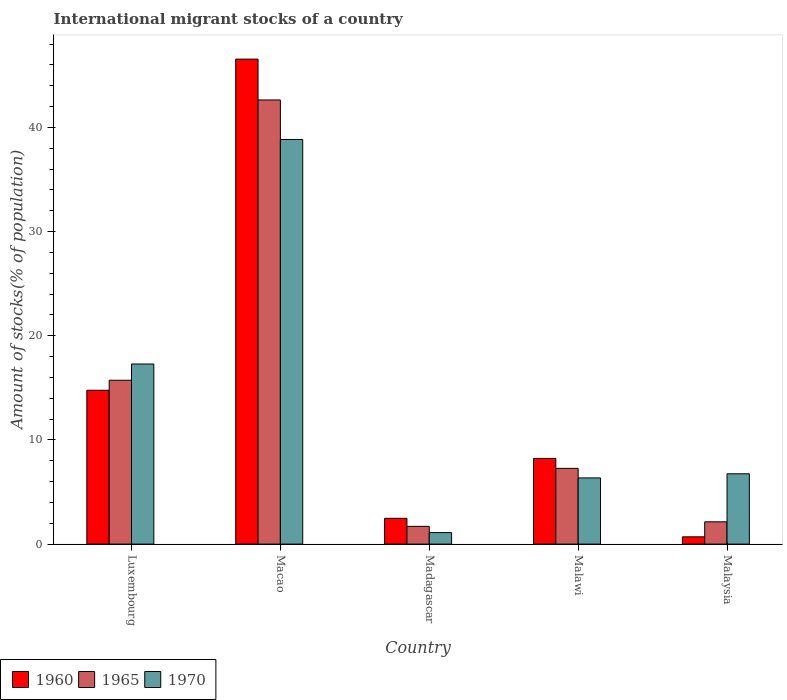How many different coloured bars are there?
Give a very brief answer. 3. How many groups of bars are there?
Give a very brief answer. 5. Are the number of bars per tick equal to the number of legend labels?
Offer a terse response. Yes. Are the number of bars on each tick of the X-axis equal?
Offer a terse response. Yes. How many bars are there on the 4th tick from the left?
Provide a short and direct response. 3. How many bars are there on the 1st tick from the right?
Ensure brevity in your answer.  3. What is the label of the 2nd group of bars from the left?
Your answer should be very brief. Macao. In how many cases, is the number of bars for a given country not equal to the number of legend labels?
Provide a succinct answer. 0. What is the amount of stocks in in 1960 in Malaysia?
Offer a terse response. 0.7. Across all countries, what is the maximum amount of stocks in in 1965?
Your response must be concise. 42.64. Across all countries, what is the minimum amount of stocks in in 1965?
Your answer should be very brief. 1.7. In which country was the amount of stocks in in 1960 maximum?
Your answer should be compact. Macao. In which country was the amount of stocks in in 1960 minimum?
Your response must be concise. Malaysia. What is the total amount of stocks in in 1960 in the graph?
Ensure brevity in your answer.  72.73. What is the difference between the amount of stocks in in 1965 in Luxembourg and that in Madagascar?
Provide a succinct answer. 14.03. What is the difference between the amount of stocks in in 1965 in Malaysia and the amount of stocks in in 1960 in Malawi?
Keep it short and to the point. -6.09. What is the average amount of stocks in in 1960 per country?
Make the answer very short. 14.55. What is the difference between the amount of stocks in of/in 1970 and amount of stocks in of/in 1965 in Macao?
Offer a very short reply. -3.79. In how many countries, is the amount of stocks in in 1965 greater than 4 %?
Give a very brief answer. 3. What is the ratio of the amount of stocks in in 1970 in Luxembourg to that in Madagascar?
Offer a terse response. 15.66. What is the difference between the highest and the second highest amount of stocks in in 1965?
Keep it short and to the point. 35.37. What is the difference between the highest and the lowest amount of stocks in in 1960?
Your answer should be very brief. 45.86. What does the 3rd bar from the left in Madagascar represents?
Provide a succinct answer. 1970. What does the 3rd bar from the right in Macao represents?
Give a very brief answer. 1960. Is it the case that in every country, the sum of the amount of stocks in in 1960 and amount of stocks in in 1965 is greater than the amount of stocks in in 1970?
Provide a short and direct response. No. How many bars are there?
Ensure brevity in your answer.  15. Are all the bars in the graph horizontal?
Your answer should be compact. No. How many countries are there in the graph?
Your answer should be very brief. 5. What is the difference between two consecutive major ticks on the Y-axis?
Ensure brevity in your answer.  10. Are the values on the major ticks of Y-axis written in scientific E-notation?
Offer a very short reply. No. How many legend labels are there?
Your answer should be compact. 3. How are the legend labels stacked?
Provide a succinct answer. Horizontal. What is the title of the graph?
Your answer should be very brief. International migrant stocks of a country. What is the label or title of the Y-axis?
Your answer should be very brief. Amount of stocks(% of population). What is the Amount of stocks(% of population) of 1960 in Luxembourg?
Provide a short and direct response. 14.77. What is the Amount of stocks(% of population) of 1965 in Luxembourg?
Make the answer very short. 15.73. What is the Amount of stocks(% of population) of 1970 in Luxembourg?
Provide a succinct answer. 17.29. What is the Amount of stocks(% of population) in 1960 in Macao?
Your response must be concise. 46.56. What is the Amount of stocks(% of population) of 1965 in Macao?
Offer a very short reply. 42.64. What is the Amount of stocks(% of population) of 1970 in Macao?
Make the answer very short. 38.85. What is the Amount of stocks(% of population) in 1960 in Madagascar?
Ensure brevity in your answer.  2.48. What is the Amount of stocks(% of population) in 1965 in Madagascar?
Offer a terse response. 1.7. What is the Amount of stocks(% of population) in 1970 in Madagascar?
Provide a succinct answer. 1.1. What is the Amount of stocks(% of population) of 1960 in Malawi?
Provide a short and direct response. 8.23. What is the Amount of stocks(% of population) of 1965 in Malawi?
Ensure brevity in your answer.  7.27. What is the Amount of stocks(% of population) of 1970 in Malawi?
Provide a short and direct response. 6.35. What is the Amount of stocks(% of population) of 1960 in Malaysia?
Keep it short and to the point. 0.7. What is the Amount of stocks(% of population) in 1965 in Malaysia?
Make the answer very short. 2.14. What is the Amount of stocks(% of population) in 1970 in Malaysia?
Make the answer very short. 6.75. Across all countries, what is the maximum Amount of stocks(% of population) of 1960?
Give a very brief answer. 46.56. Across all countries, what is the maximum Amount of stocks(% of population) in 1965?
Your answer should be very brief. 42.64. Across all countries, what is the maximum Amount of stocks(% of population) in 1970?
Your response must be concise. 38.85. Across all countries, what is the minimum Amount of stocks(% of population) of 1960?
Your answer should be compact. 0.7. Across all countries, what is the minimum Amount of stocks(% of population) in 1965?
Your answer should be compact. 1.7. Across all countries, what is the minimum Amount of stocks(% of population) in 1970?
Offer a terse response. 1.1. What is the total Amount of stocks(% of population) in 1960 in the graph?
Ensure brevity in your answer.  72.73. What is the total Amount of stocks(% of population) in 1965 in the graph?
Provide a succinct answer. 69.49. What is the total Amount of stocks(% of population) in 1970 in the graph?
Your answer should be compact. 70.35. What is the difference between the Amount of stocks(% of population) in 1960 in Luxembourg and that in Macao?
Provide a succinct answer. -31.79. What is the difference between the Amount of stocks(% of population) of 1965 in Luxembourg and that in Macao?
Your response must be concise. -26.91. What is the difference between the Amount of stocks(% of population) of 1970 in Luxembourg and that in Macao?
Your response must be concise. -21.56. What is the difference between the Amount of stocks(% of population) of 1960 in Luxembourg and that in Madagascar?
Give a very brief answer. 12.29. What is the difference between the Amount of stocks(% of population) of 1965 in Luxembourg and that in Madagascar?
Provide a short and direct response. 14.03. What is the difference between the Amount of stocks(% of population) in 1970 in Luxembourg and that in Madagascar?
Your answer should be compact. 16.19. What is the difference between the Amount of stocks(% of population) of 1960 in Luxembourg and that in Malawi?
Offer a very short reply. 6.54. What is the difference between the Amount of stocks(% of population) in 1965 in Luxembourg and that in Malawi?
Your response must be concise. 8.46. What is the difference between the Amount of stocks(% of population) in 1970 in Luxembourg and that in Malawi?
Keep it short and to the point. 10.94. What is the difference between the Amount of stocks(% of population) in 1960 in Luxembourg and that in Malaysia?
Offer a terse response. 14.07. What is the difference between the Amount of stocks(% of population) in 1965 in Luxembourg and that in Malaysia?
Your answer should be compact. 13.59. What is the difference between the Amount of stocks(% of population) in 1970 in Luxembourg and that in Malaysia?
Offer a very short reply. 10.54. What is the difference between the Amount of stocks(% of population) in 1960 in Macao and that in Madagascar?
Give a very brief answer. 44.08. What is the difference between the Amount of stocks(% of population) of 1965 in Macao and that in Madagascar?
Make the answer very short. 40.94. What is the difference between the Amount of stocks(% of population) of 1970 in Macao and that in Madagascar?
Ensure brevity in your answer.  37.74. What is the difference between the Amount of stocks(% of population) of 1960 in Macao and that in Malawi?
Ensure brevity in your answer.  38.33. What is the difference between the Amount of stocks(% of population) of 1965 in Macao and that in Malawi?
Provide a short and direct response. 35.37. What is the difference between the Amount of stocks(% of population) of 1970 in Macao and that in Malawi?
Your answer should be very brief. 32.49. What is the difference between the Amount of stocks(% of population) in 1960 in Macao and that in Malaysia?
Provide a short and direct response. 45.86. What is the difference between the Amount of stocks(% of population) in 1965 in Macao and that in Malaysia?
Your answer should be compact. 40.5. What is the difference between the Amount of stocks(% of population) in 1970 in Macao and that in Malaysia?
Offer a very short reply. 32.1. What is the difference between the Amount of stocks(% of population) in 1960 in Madagascar and that in Malawi?
Keep it short and to the point. -5.75. What is the difference between the Amount of stocks(% of population) in 1965 in Madagascar and that in Malawi?
Make the answer very short. -5.57. What is the difference between the Amount of stocks(% of population) of 1970 in Madagascar and that in Malawi?
Ensure brevity in your answer.  -5.25. What is the difference between the Amount of stocks(% of population) in 1960 in Madagascar and that in Malaysia?
Give a very brief answer. 1.78. What is the difference between the Amount of stocks(% of population) of 1965 in Madagascar and that in Malaysia?
Provide a succinct answer. -0.43. What is the difference between the Amount of stocks(% of population) in 1970 in Madagascar and that in Malaysia?
Offer a terse response. -5.65. What is the difference between the Amount of stocks(% of population) of 1960 in Malawi and that in Malaysia?
Keep it short and to the point. 7.53. What is the difference between the Amount of stocks(% of population) of 1965 in Malawi and that in Malaysia?
Provide a succinct answer. 5.13. What is the difference between the Amount of stocks(% of population) of 1970 in Malawi and that in Malaysia?
Provide a short and direct response. -0.4. What is the difference between the Amount of stocks(% of population) in 1960 in Luxembourg and the Amount of stocks(% of population) in 1965 in Macao?
Give a very brief answer. -27.87. What is the difference between the Amount of stocks(% of population) in 1960 in Luxembourg and the Amount of stocks(% of population) in 1970 in Macao?
Provide a short and direct response. -24.08. What is the difference between the Amount of stocks(% of population) in 1965 in Luxembourg and the Amount of stocks(% of population) in 1970 in Macao?
Ensure brevity in your answer.  -23.12. What is the difference between the Amount of stocks(% of population) of 1960 in Luxembourg and the Amount of stocks(% of population) of 1965 in Madagascar?
Give a very brief answer. 13.06. What is the difference between the Amount of stocks(% of population) of 1960 in Luxembourg and the Amount of stocks(% of population) of 1970 in Madagascar?
Give a very brief answer. 13.67. What is the difference between the Amount of stocks(% of population) in 1965 in Luxembourg and the Amount of stocks(% of population) in 1970 in Madagascar?
Provide a short and direct response. 14.63. What is the difference between the Amount of stocks(% of population) of 1960 in Luxembourg and the Amount of stocks(% of population) of 1965 in Malawi?
Ensure brevity in your answer.  7.5. What is the difference between the Amount of stocks(% of population) in 1960 in Luxembourg and the Amount of stocks(% of population) in 1970 in Malawi?
Provide a succinct answer. 8.42. What is the difference between the Amount of stocks(% of population) of 1965 in Luxembourg and the Amount of stocks(% of population) of 1970 in Malawi?
Provide a succinct answer. 9.38. What is the difference between the Amount of stocks(% of population) in 1960 in Luxembourg and the Amount of stocks(% of population) in 1965 in Malaysia?
Your answer should be very brief. 12.63. What is the difference between the Amount of stocks(% of population) in 1960 in Luxembourg and the Amount of stocks(% of population) in 1970 in Malaysia?
Provide a succinct answer. 8.02. What is the difference between the Amount of stocks(% of population) of 1965 in Luxembourg and the Amount of stocks(% of population) of 1970 in Malaysia?
Ensure brevity in your answer.  8.98. What is the difference between the Amount of stocks(% of population) of 1960 in Macao and the Amount of stocks(% of population) of 1965 in Madagascar?
Your answer should be compact. 44.86. What is the difference between the Amount of stocks(% of population) in 1960 in Macao and the Amount of stocks(% of population) in 1970 in Madagascar?
Keep it short and to the point. 45.46. What is the difference between the Amount of stocks(% of population) in 1965 in Macao and the Amount of stocks(% of population) in 1970 in Madagascar?
Your answer should be very brief. 41.54. What is the difference between the Amount of stocks(% of population) in 1960 in Macao and the Amount of stocks(% of population) in 1965 in Malawi?
Your response must be concise. 39.29. What is the difference between the Amount of stocks(% of population) of 1960 in Macao and the Amount of stocks(% of population) of 1970 in Malawi?
Offer a very short reply. 40.21. What is the difference between the Amount of stocks(% of population) in 1965 in Macao and the Amount of stocks(% of population) in 1970 in Malawi?
Give a very brief answer. 36.29. What is the difference between the Amount of stocks(% of population) in 1960 in Macao and the Amount of stocks(% of population) in 1965 in Malaysia?
Your answer should be compact. 44.42. What is the difference between the Amount of stocks(% of population) in 1960 in Macao and the Amount of stocks(% of population) in 1970 in Malaysia?
Keep it short and to the point. 39.81. What is the difference between the Amount of stocks(% of population) of 1965 in Macao and the Amount of stocks(% of population) of 1970 in Malaysia?
Make the answer very short. 35.89. What is the difference between the Amount of stocks(% of population) of 1960 in Madagascar and the Amount of stocks(% of population) of 1965 in Malawi?
Your answer should be compact. -4.79. What is the difference between the Amount of stocks(% of population) in 1960 in Madagascar and the Amount of stocks(% of population) in 1970 in Malawi?
Give a very brief answer. -3.88. What is the difference between the Amount of stocks(% of population) in 1965 in Madagascar and the Amount of stocks(% of population) in 1970 in Malawi?
Make the answer very short. -4.65. What is the difference between the Amount of stocks(% of population) in 1960 in Madagascar and the Amount of stocks(% of population) in 1965 in Malaysia?
Give a very brief answer. 0.34. What is the difference between the Amount of stocks(% of population) in 1960 in Madagascar and the Amount of stocks(% of population) in 1970 in Malaysia?
Give a very brief answer. -4.27. What is the difference between the Amount of stocks(% of population) in 1965 in Madagascar and the Amount of stocks(% of population) in 1970 in Malaysia?
Provide a succinct answer. -5.04. What is the difference between the Amount of stocks(% of population) of 1960 in Malawi and the Amount of stocks(% of population) of 1965 in Malaysia?
Your answer should be very brief. 6.09. What is the difference between the Amount of stocks(% of population) in 1960 in Malawi and the Amount of stocks(% of population) in 1970 in Malaysia?
Offer a very short reply. 1.48. What is the difference between the Amount of stocks(% of population) in 1965 in Malawi and the Amount of stocks(% of population) in 1970 in Malaysia?
Your response must be concise. 0.52. What is the average Amount of stocks(% of population) in 1960 per country?
Ensure brevity in your answer.  14.55. What is the average Amount of stocks(% of population) of 1965 per country?
Your answer should be compact. 13.9. What is the average Amount of stocks(% of population) in 1970 per country?
Make the answer very short. 14.07. What is the difference between the Amount of stocks(% of population) in 1960 and Amount of stocks(% of population) in 1965 in Luxembourg?
Give a very brief answer. -0.96. What is the difference between the Amount of stocks(% of population) of 1960 and Amount of stocks(% of population) of 1970 in Luxembourg?
Keep it short and to the point. -2.52. What is the difference between the Amount of stocks(% of population) of 1965 and Amount of stocks(% of population) of 1970 in Luxembourg?
Keep it short and to the point. -1.56. What is the difference between the Amount of stocks(% of population) of 1960 and Amount of stocks(% of population) of 1965 in Macao?
Provide a short and direct response. 3.92. What is the difference between the Amount of stocks(% of population) of 1960 and Amount of stocks(% of population) of 1970 in Macao?
Ensure brevity in your answer.  7.71. What is the difference between the Amount of stocks(% of population) of 1965 and Amount of stocks(% of population) of 1970 in Macao?
Offer a very short reply. 3.79. What is the difference between the Amount of stocks(% of population) of 1960 and Amount of stocks(% of population) of 1965 in Madagascar?
Offer a terse response. 0.77. What is the difference between the Amount of stocks(% of population) in 1960 and Amount of stocks(% of population) in 1970 in Madagascar?
Offer a terse response. 1.37. What is the difference between the Amount of stocks(% of population) of 1965 and Amount of stocks(% of population) of 1970 in Madagascar?
Offer a terse response. 0.6. What is the difference between the Amount of stocks(% of population) of 1960 and Amount of stocks(% of population) of 1965 in Malawi?
Keep it short and to the point. 0.96. What is the difference between the Amount of stocks(% of population) in 1960 and Amount of stocks(% of population) in 1970 in Malawi?
Your answer should be compact. 1.87. What is the difference between the Amount of stocks(% of population) in 1965 and Amount of stocks(% of population) in 1970 in Malawi?
Make the answer very short. 0.92. What is the difference between the Amount of stocks(% of population) of 1960 and Amount of stocks(% of population) of 1965 in Malaysia?
Provide a short and direct response. -1.44. What is the difference between the Amount of stocks(% of population) in 1960 and Amount of stocks(% of population) in 1970 in Malaysia?
Give a very brief answer. -6.05. What is the difference between the Amount of stocks(% of population) in 1965 and Amount of stocks(% of population) in 1970 in Malaysia?
Ensure brevity in your answer.  -4.61. What is the ratio of the Amount of stocks(% of population) in 1960 in Luxembourg to that in Macao?
Give a very brief answer. 0.32. What is the ratio of the Amount of stocks(% of population) of 1965 in Luxembourg to that in Macao?
Provide a short and direct response. 0.37. What is the ratio of the Amount of stocks(% of population) in 1970 in Luxembourg to that in Macao?
Your response must be concise. 0.45. What is the ratio of the Amount of stocks(% of population) of 1960 in Luxembourg to that in Madagascar?
Your answer should be very brief. 5.96. What is the ratio of the Amount of stocks(% of population) of 1965 in Luxembourg to that in Madagascar?
Ensure brevity in your answer.  9.23. What is the ratio of the Amount of stocks(% of population) of 1970 in Luxembourg to that in Madagascar?
Offer a terse response. 15.66. What is the ratio of the Amount of stocks(% of population) of 1960 in Luxembourg to that in Malawi?
Your response must be concise. 1.8. What is the ratio of the Amount of stocks(% of population) of 1965 in Luxembourg to that in Malawi?
Offer a terse response. 2.16. What is the ratio of the Amount of stocks(% of population) in 1970 in Luxembourg to that in Malawi?
Your response must be concise. 2.72. What is the ratio of the Amount of stocks(% of population) in 1960 in Luxembourg to that in Malaysia?
Offer a terse response. 21.19. What is the ratio of the Amount of stocks(% of population) in 1965 in Luxembourg to that in Malaysia?
Offer a very short reply. 7.36. What is the ratio of the Amount of stocks(% of population) of 1970 in Luxembourg to that in Malaysia?
Give a very brief answer. 2.56. What is the ratio of the Amount of stocks(% of population) in 1960 in Macao to that in Madagascar?
Provide a succinct answer. 18.8. What is the ratio of the Amount of stocks(% of population) of 1965 in Macao to that in Madagascar?
Ensure brevity in your answer.  25.01. What is the ratio of the Amount of stocks(% of population) of 1970 in Macao to that in Madagascar?
Your answer should be very brief. 35.19. What is the ratio of the Amount of stocks(% of population) in 1960 in Macao to that in Malawi?
Provide a short and direct response. 5.66. What is the ratio of the Amount of stocks(% of population) in 1965 in Macao to that in Malawi?
Provide a short and direct response. 5.87. What is the ratio of the Amount of stocks(% of population) of 1970 in Macao to that in Malawi?
Your answer should be very brief. 6.11. What is the ratio of the Amount of stocks(% of population) of 1960 in Macao to that in Malaysia?
Provide a succinct answer. 66.79. What is the ratio of the Amount of stocks(% of population) of 1965 in Macao to that in Malaysia?
Offer a terse response. 19.94. What is the ratio of the Amount of stocks(% of population) of 1970 in Macao to that in Malaysia?
Make the answer very short. 5.76. What is the ratio of the Amount of stocks(% of population) in 1960 in Madagascar to that in Malawi?
Offer a terse response. 0.3. What is the ratio of the Amount of stocks(% of population) of 1965 in Madagascar to that in Malawi?
Your answer should be very brief. 0.23. What is the ratio of the Amount of stocks(% of population) of 1970 in Madagascar to that in Malawi?
Your answer should be very brief. 0.17. What is the ratio of the Amount of stocks(% of population) of 1960 in Madagascar to that in Malaysia?
Ensure brevity in your answer.  3.55. What is the ratio of the Amount of stocks(% of population) of 1965 in Madagascar to that in Malaysia?
Ensure brevity in your answer.  0.8. What is the ratio of the Amount of stocks(% of population) of 1970 in Madagascar to that in Malaysia?
Your answer should be compact. 0.16. What is the ratio of the Amount of stocks(% of population) in 1960 in Malawi to that in Malaysia?
Offer a very short reply. 11.8. What is the ratio of the Amount of stocks(% of population) in 1965 in Malawi to that in Malaysia?
Your answer should be very brief. 3.4. What is the ratio of the Amount of stocks(% of population) of 1970 in Malawi to that in Malaysia?
Offer a terse response. 0.94. What is the difference between the highest and the second highest Amount of stocks(% of population) of 1960?
Offer a very short reply. 31.79. What is the difference between the highest and the second highest Amount of stocks(% of population) of 1965?
Ensure brevity in your answer.  26.91. What is the difference between the highest and the second highest Amount of stocks(% of population) in 1970?
Offer a terse response. 21.56. What is the difference between the highest and the lowest Amount of stocks(% of population) in 1960?
Your answer should be compact. 45.86. What is the difference between the highest and the lowest Amount of stocks(% of population) in 1965?
Your answer should be very brief. 40.94. What is the difference between the highest and the lowest Amount of stocks(% of population) in 1970?
Ensure brevity in your answer.  37.74. 